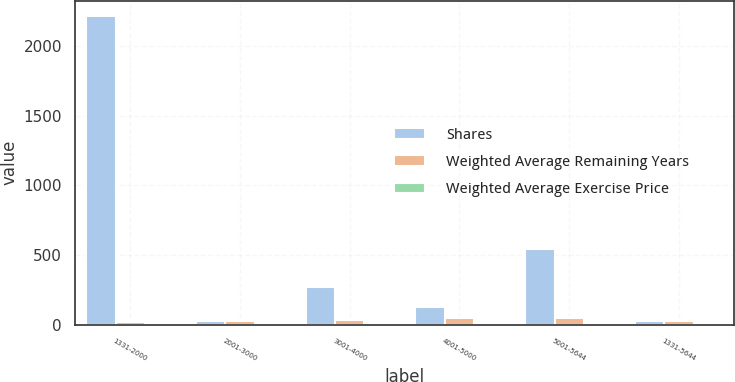<chart> <loc_0><loc_0><loc_500><loc_500><stacked_bar_chart><ecel><fcel>1331-2000<fcel>2001-3000<fcel>3001-4000<fcel>4001-5000<fcel>5001-5644<fcel>1331-5644<nl><fcel>Shares<fcel>2215<fcel>27.03<fcel>273<fcel>125<fcel>544<fcel>27.03<nl><fcel>Weighted Average Remaining Years<fcel>18.62<fcel>27.09<fcel>33.2<fcel>47.11<fcel>51.38<fcel>26.97<nl><fcel>Weighted Average Exercise Price<fcel>3.25<fcel>3.85<fcel>3.38<fcel>0.02<fcel>0.06<fcel>3.49<nl></chart> 